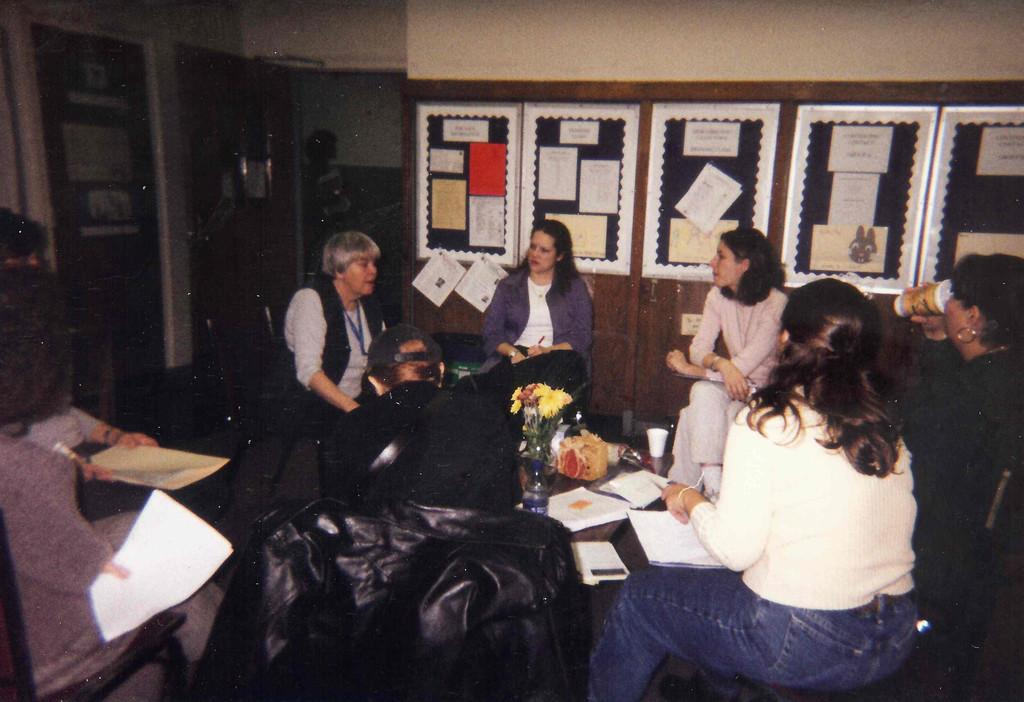What can be seen on the wall in the image? There are photo frames on the wall in the image. What are the people in the image doing? There are people sitting in the image. What is on the table in the image? There is a table in the image with a glass, papers, and a flower flask on it. What type of decision can be seen being made by the people in the image? There is no indication of a decision being made in the image; it simply shows people sitting and a table with various items on it. Can you describe the self that is present in the image? There is no self or person represented as the subject of the image; it focuses on the objects and people in the scene. 